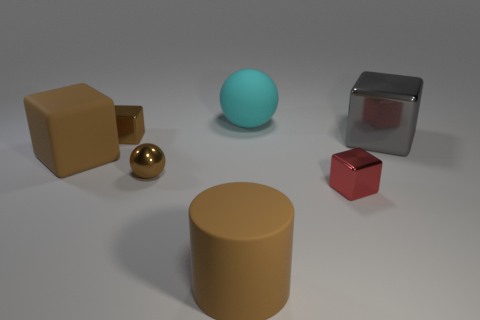The block that is both on the right side of the small brown shiny sphere and left of the gray metal cube is made of what material?
Keep it short and to the point. Metal. There is a tiny thing that is behind the gray cube; does it have the same color as the sphere in front of the large gray object?
Offer a very short reply. Yes. How many cyan things are either big cylinders or matte spheres?
Make the answer very short. 1. Is the number of cyan matte things that are in front of the red object less than the number of tiny brown metallic spheres to the left of the matte block?
Give a very brief answer. No. Is there a cube of the same size as the metallic sphere?
Provide a short and direct response. Yes. There is a rubber ball that is behind the red block; is its size the same as the small brown block?
Offer a terse response. No. Are there more big brown matte cylinders than large purple cylinders?
Ensure brevity in your answer.  Yes. Are there any other large things of the same shape as the big metal object?
Ensure brevity in your answer.  Yes. The tiny red metal thing in front of the large cyan rubber sphere has what shape?
Offer a terse response. Cube. There is a big brown rubber thing in front of the small metallic cube that is to the right of the big brown rubber cylinder; what number of small brown balls are right of it?
Keep it short and to the point. 0. 